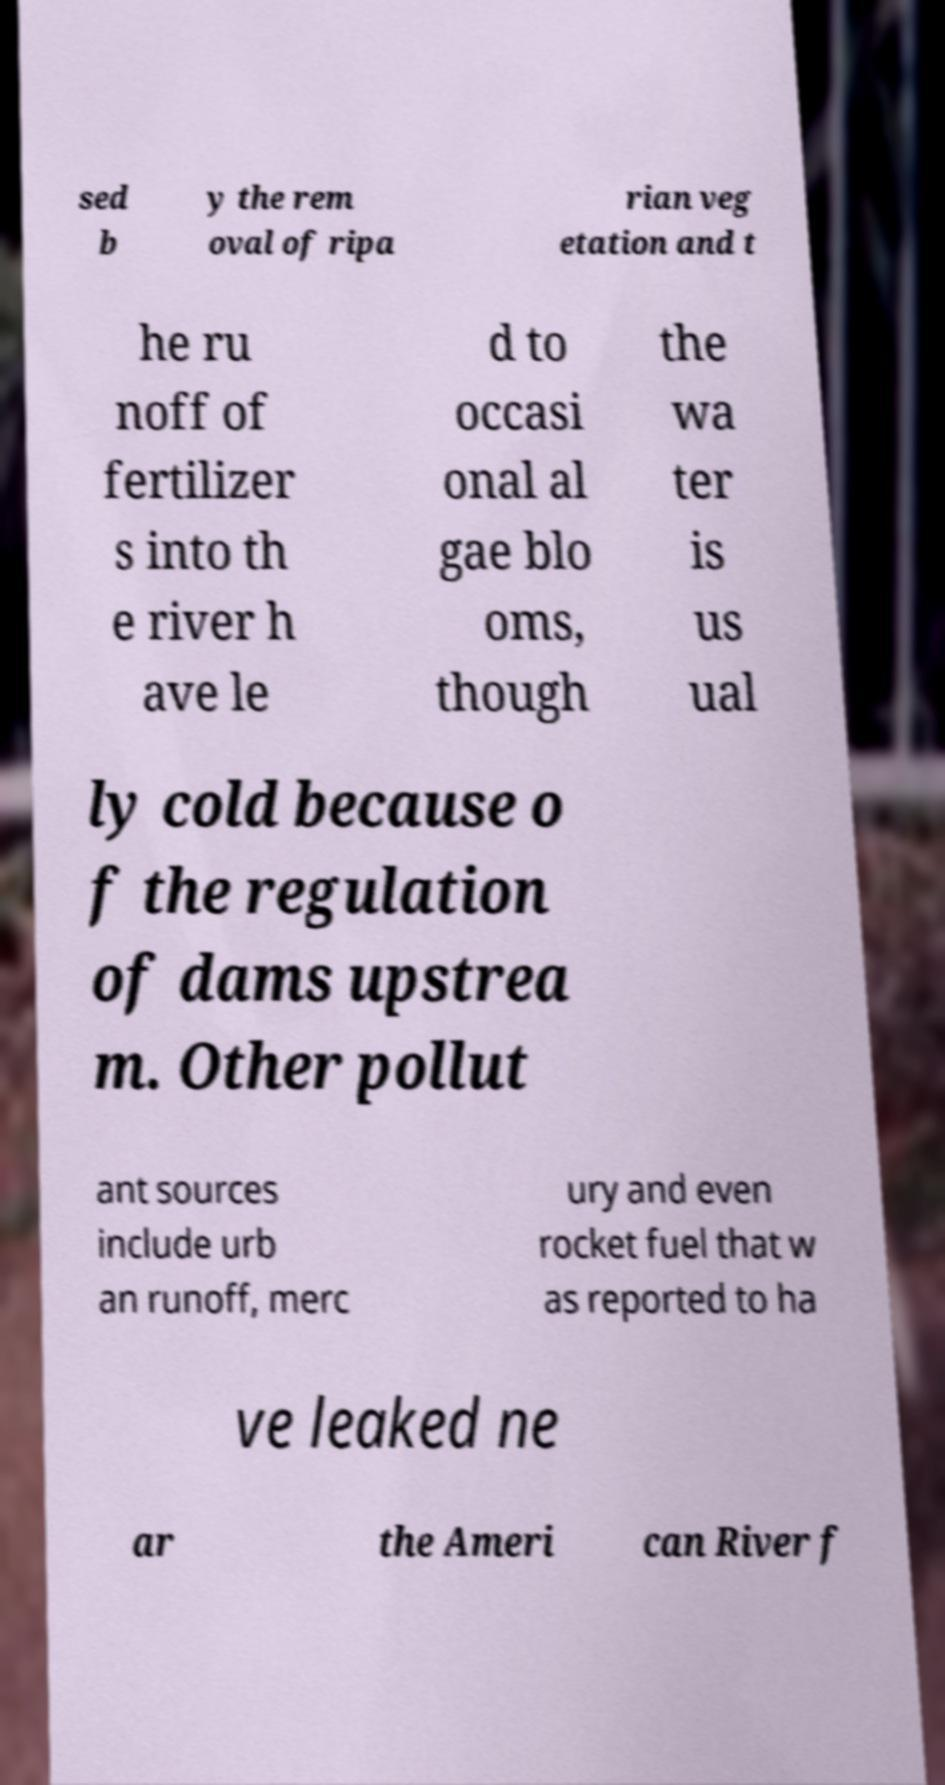Please read and relay the text visible in this image. What does it say? sed b y the rem oval of ripa rian veg etation and t he ru noff of fertilizer s into th e river h ave le d to occasi onal al gae blo oms, though the wa ter is us ual ly cold because o f the regulation of dams upstrea m. Other pollut ant sources include urb an runoff, merc ury and even rocket fuel that w as reported to ha ve leaked ne ar the Ameri can River f 